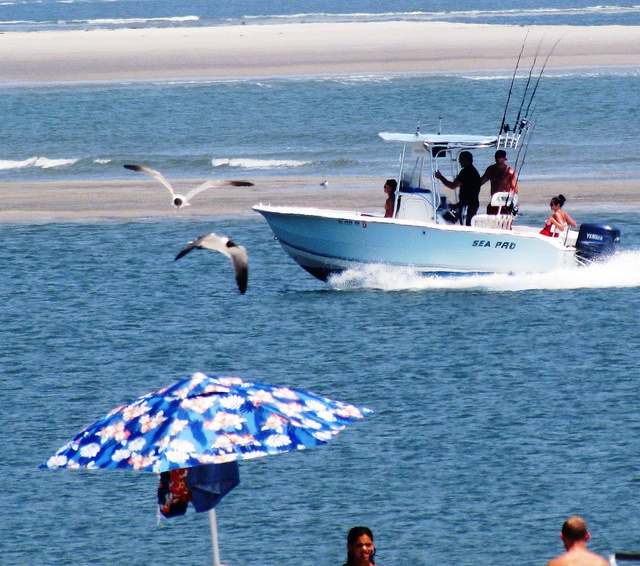Describe the objects in this image and their specific colors. I can see boat in darkgray, lightgray, lightblue, and teal tones, umbrella in darkgray, white, blue, lightblue, and darkblue tones, people in darkgray, black, navy, and gray tones, people in darkgray, tan, black, salmon, and maroon tones, and bird in darkgray, black, lightgray, and gray tones in this image. 